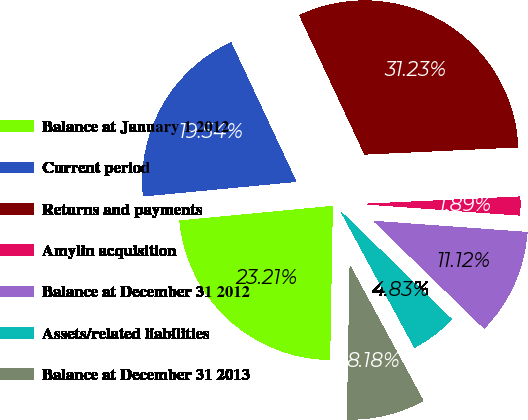Convert chart to OTSL. <chart><loc_0><loc_0><loc_500><loc_500><pie_chart><fcel>Balance at January 1 2012<fcel>Current period<fcel>Returns and payments<fcel>Amylin acquisition<fcel>Balance at December 31 2012<fcel>Assets/related liabilities<fcel>Balance at December 31 2013<nl><fcel>23.21%<fcel>19.54%<fcel>31.23%<fcel>1.89%<fcel>11.12%<fcel>4.83%<fcel>8.18%<nl></chart> 